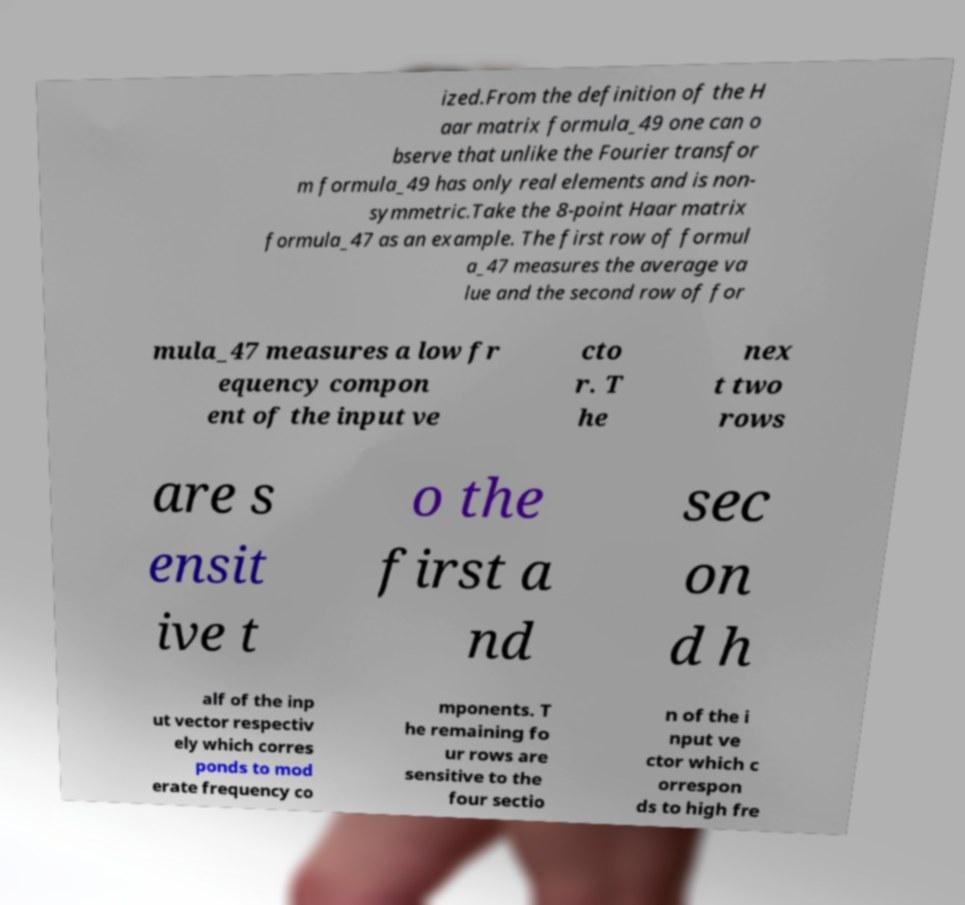For documentation purposes, I need the text within this image transcribed. Could you provide that? ized.From the definition of the H aar matrix formula_49 one can o bserve that unlike the Fourier transfor m formula_49 has only real elements and is non- symmetric.Take the 8-point Haar matrix formula_47 as an example. The first row of formul a_47 measures the average va lue and the second row of for mula_47 measures a low fr equency compon ent of the input ve cto r. T he nex t two rows are s ensit ive t o the first a nd sec on d h alf of the inp ut vector respectiv ely which corres ponds to mod erate frequency co mponents. T he remaining fo ur rows are sensitive to the four sectio n of the i nput ve ctor which c orrespon ds to high fre 